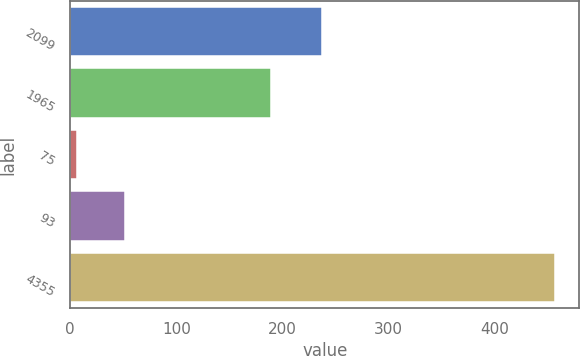Convert chart to OTSL. <chart><loc_0><loc_0><loc_500><loc_500><bar_chart><fcel>2099<fcel>1965<fcel>75<fcel>93<fcel>4355<nl><fcel>237.1<fcel>189.5<fcel>6.6<fcel>51.62<fcel>456.8<nl></chart> 